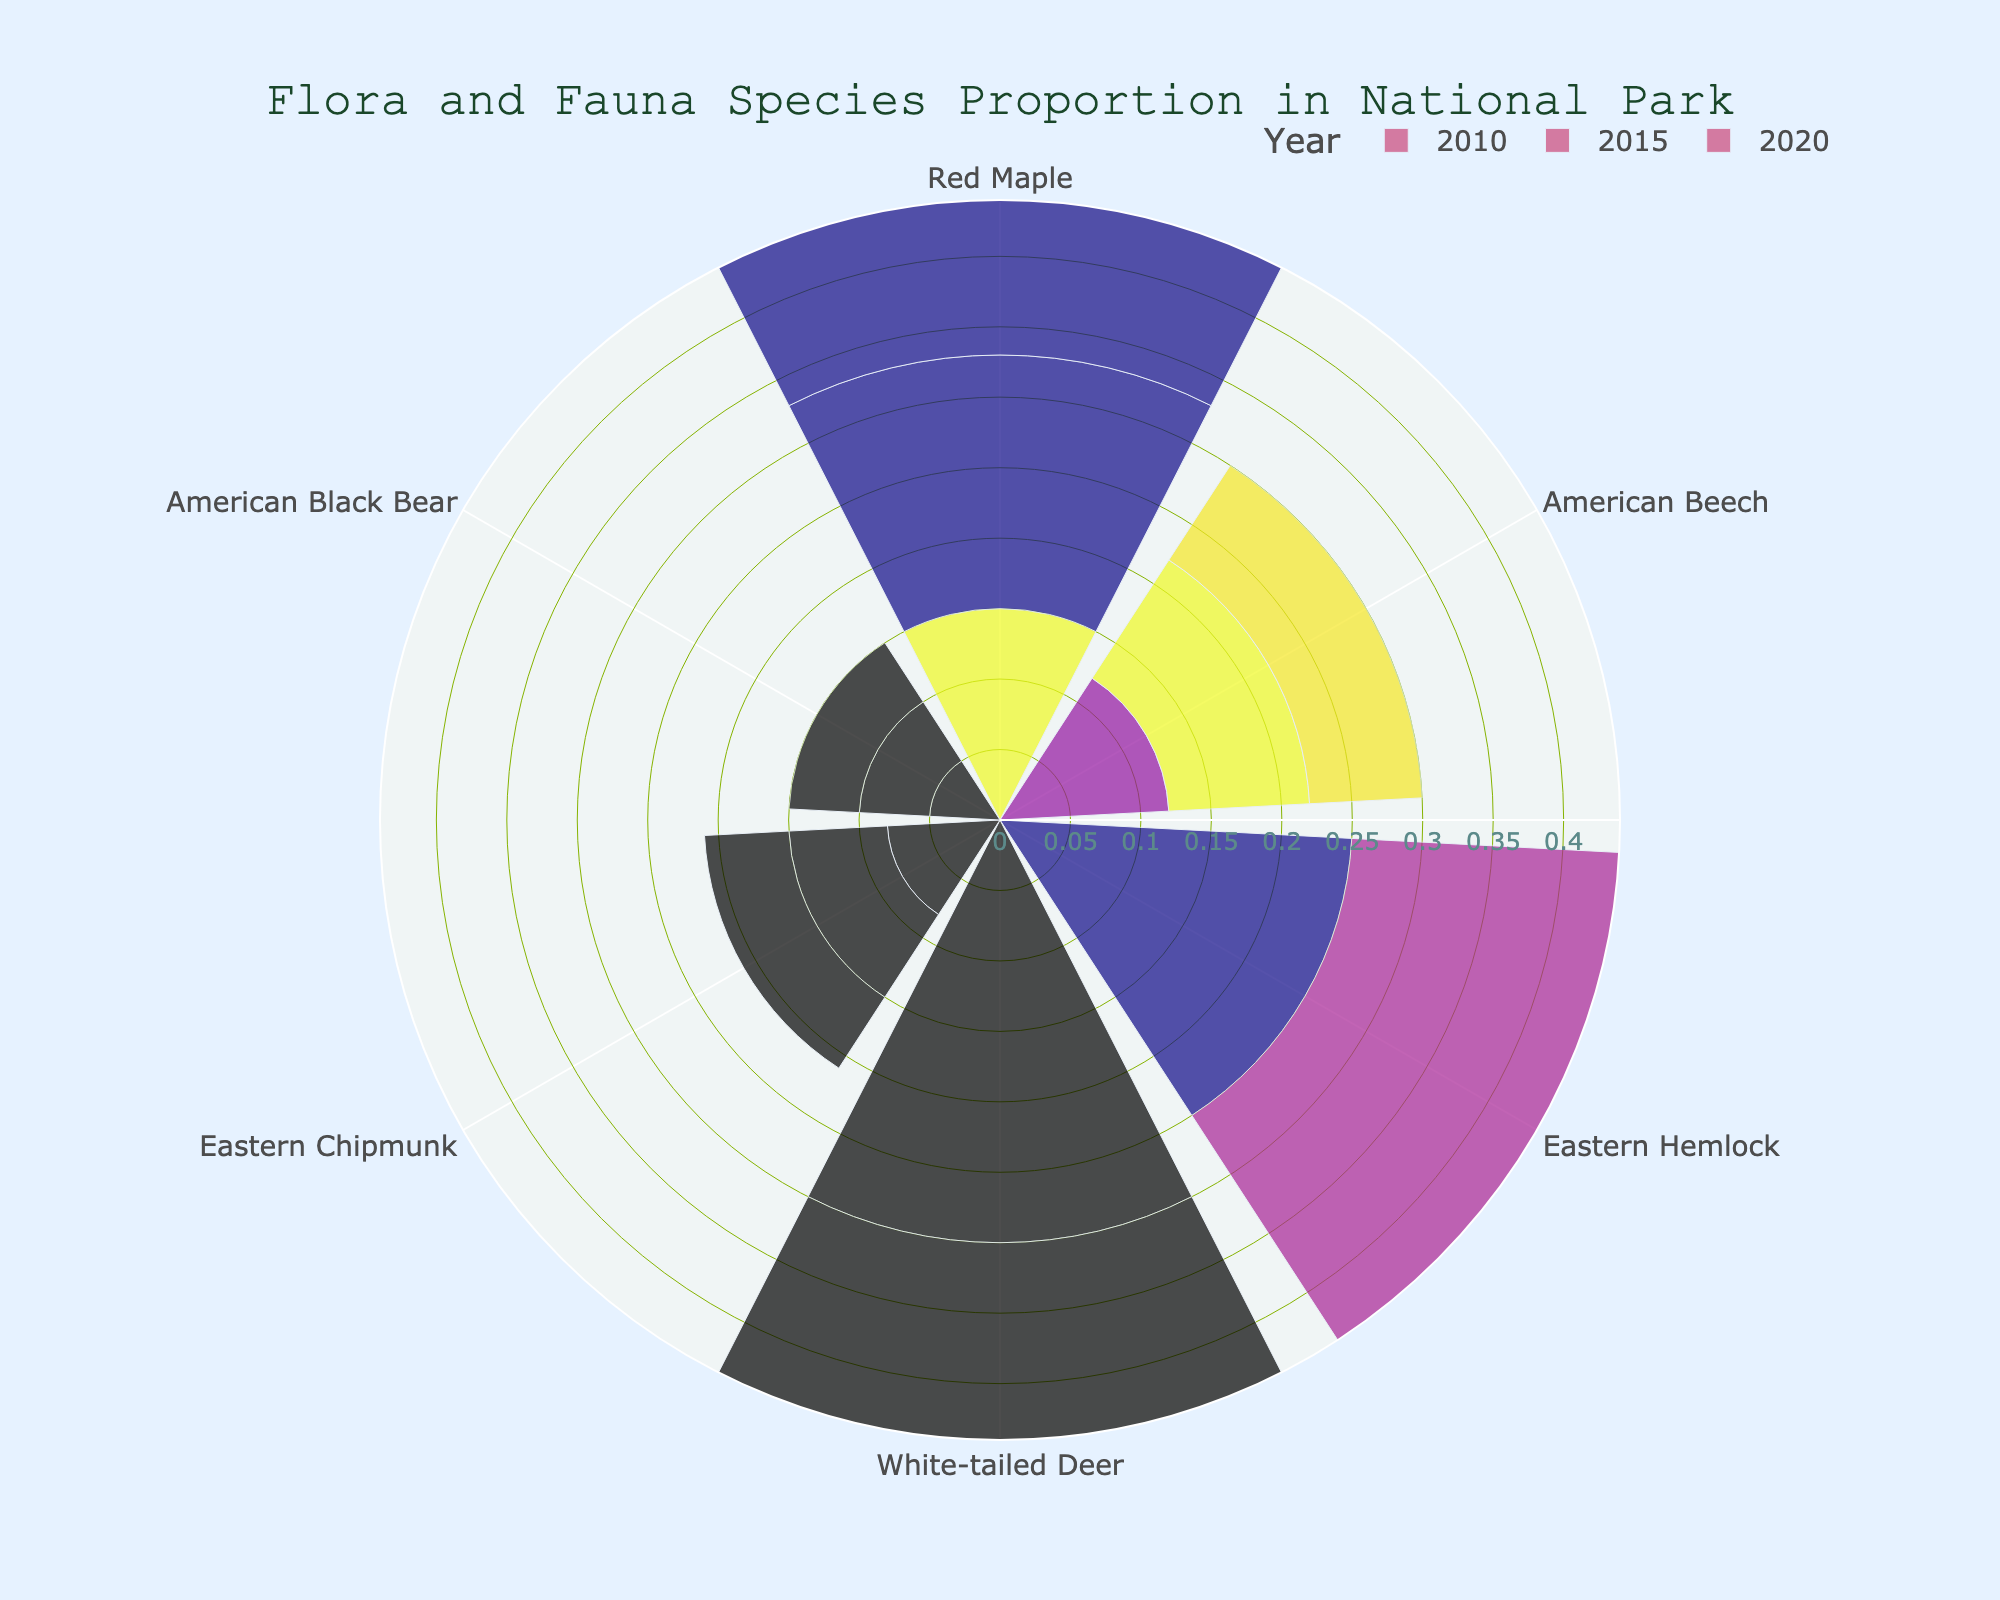What is the title of the chart? The title is prominently displayed in a larger font at the top-center of the chart. The title reads "Flora and Fauna Species Proportion in National Park".
Answer: Flora and Fauna Species Proportion in National Park How did the proportion of American Beech trees change from 2010 to 2020? By looking at the bars associated with the "American Beech" along the angular axis, you can see that the length of the bars (proportion) decreased from 0.12 in 2010 to 0.08 in 2020.
Answer: Decreased Which species had the highest proportion in any year? By comparing the lengths of the bars in different years, it's clear that the "White-tailed Deer" had the highest proportion, reaching 0.40 in 2020.
Answer: White-tailed Deer What is the proportion of Red Maple trees in 2015? Locate the segment for "Red Maple" species in 2015. The bar length for this segment indicates the proportion, which is 0.18.
Answer: 0.18 How did the proportion of Eastern Hemlock trees change from 2010 to 2020? Examine the "Eastern Hemlock" segments for 2010, 2015, and 2020. The bars indicate a decrease from 0.25 in 2010 to 0.18 in 2020.
Answer: Decreased How many species have a constant proportion over the years? Check each species to see if any have bars of the same length across all years. "American Black Bear" has a constant proportion of 0.05 in 2010, 2015, and 2020.
Answer: One Which year had the highest proportion of Eastern Chipmunks? Compare the lengths of the "Eastern Chipmunk" bars across the years. The highest proportion was in 2010, with a value of 0.08.
Answer: 2010 Compare the proportion of Red Maple and Eastern Hemlock in 2020. Which is higher? Look at the 2020 segments for both "Red Maple" and "Eastern Hemlock". The Red Maple's proportion is 0.20, which is higher than the Eastern Hemlock's 0.18.
Answer: Red Maple What is the average proportion of American Black Bears over the years? The proportions are 0.05 for each year (2010, 2015, 2020). Average is calculated by (0.05 + 0.05 + 0.05) / 3 = 0.05.
Answer: 0.05 What trend can be observed for the proportion of White-tailed Deer from 2010 to 2020? Analyze the "White-tailed Deer" segments for each year. The trend shows a consistent increase from 0.30 in 2010 to 0.40 in 2020.
Answer: Increasing 